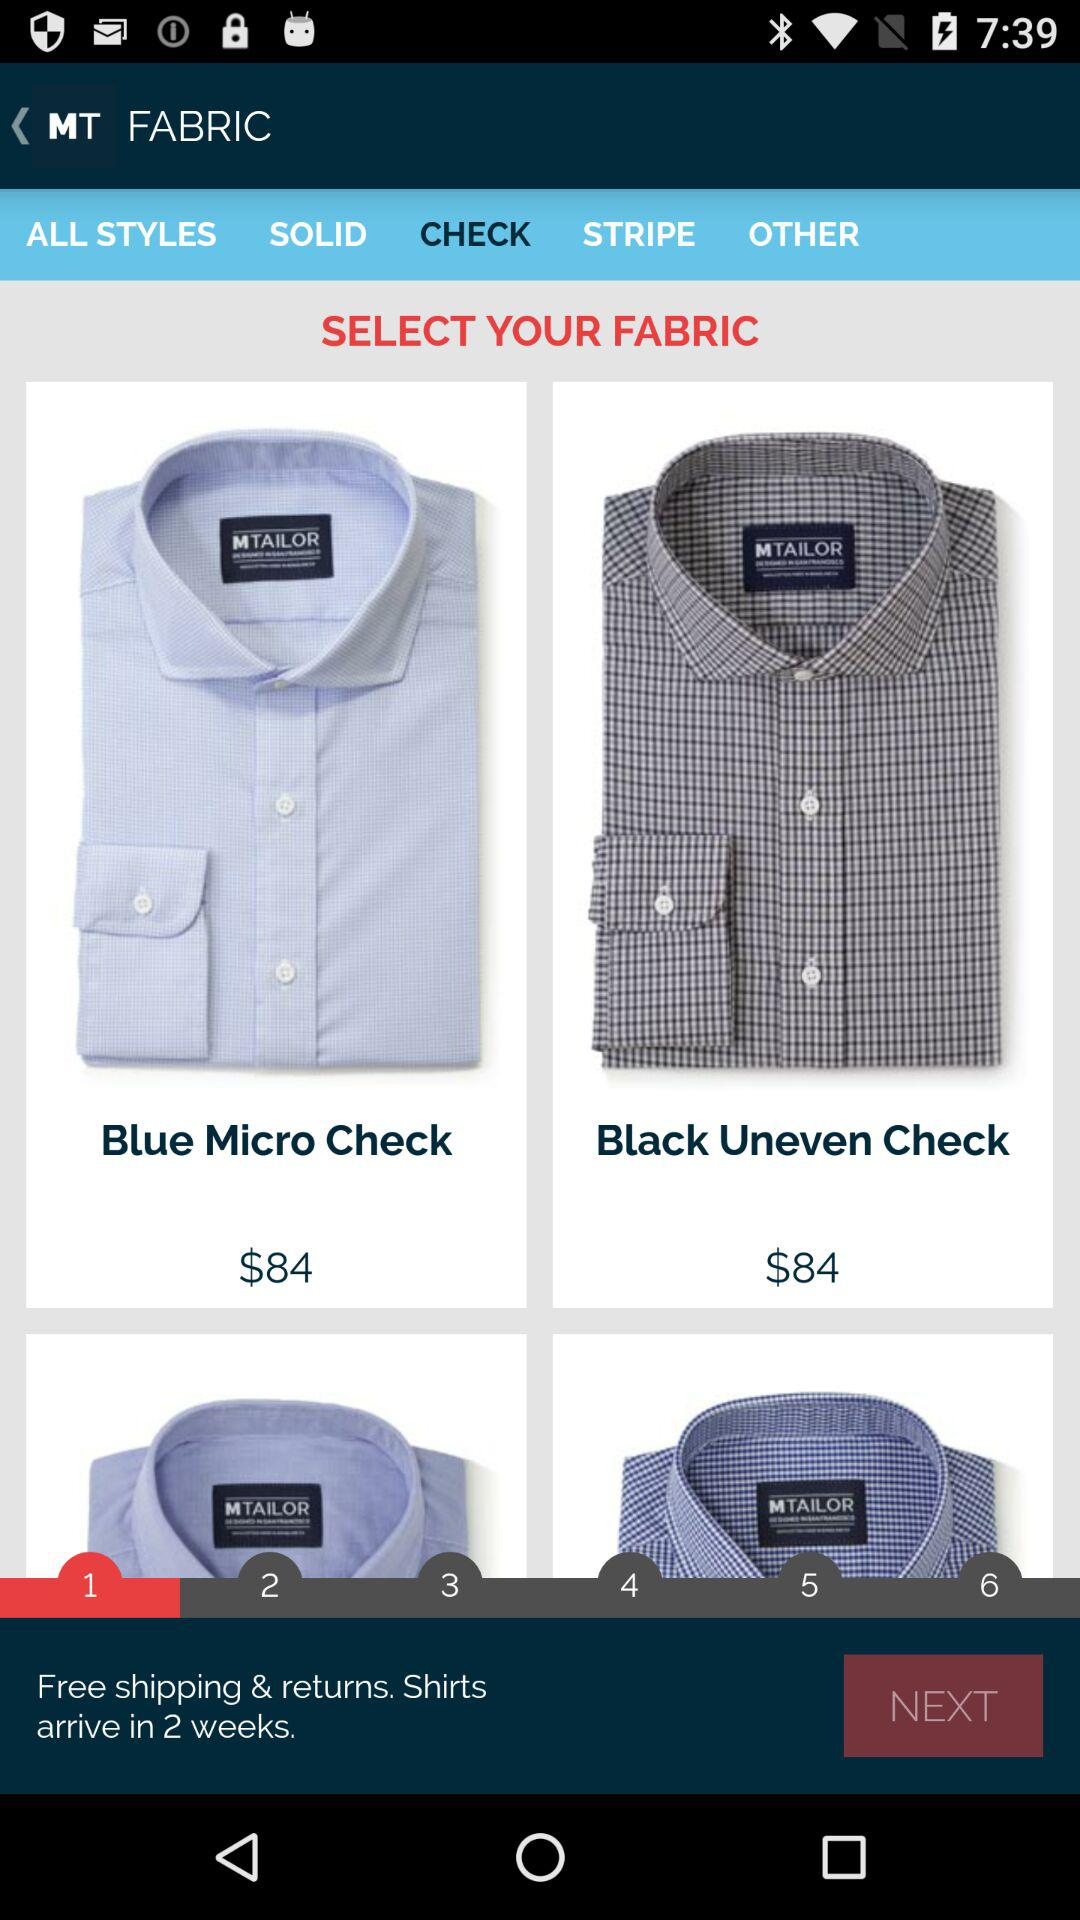What is the shipping charge? The shipping charge is free. 